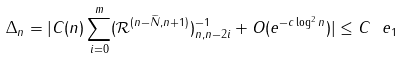Convert formula to latex. <formula><loc_0><loc_0><loc_500><loc_500>\Delta _ { n } = | C ( n ) \sum _ { i = 0 } ^ { m } ( \mathcal { R } ^ { ( n - \widetilde { N } , n + 1 ) } ) ^ { - 1 } _ { n , n - 2 i } + O ( e ^ { - c \log ^ { 2 } n } ) | \leq C \ e _ { 1 }</formula> 